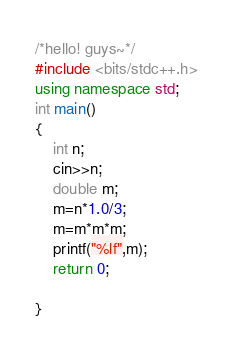<code> <loc_0><loc_0><loc_500><loc_500><_C++_>/*hello! guys~*/
#include <bits/stdc++.h>
using namespace std;
int main()
{
	int n;
	cin>>n;
	double m;
	m=n*1.0/3;
	m=m*m*m;
	printf("%lf",m);
	return 0;
	
}</code> 